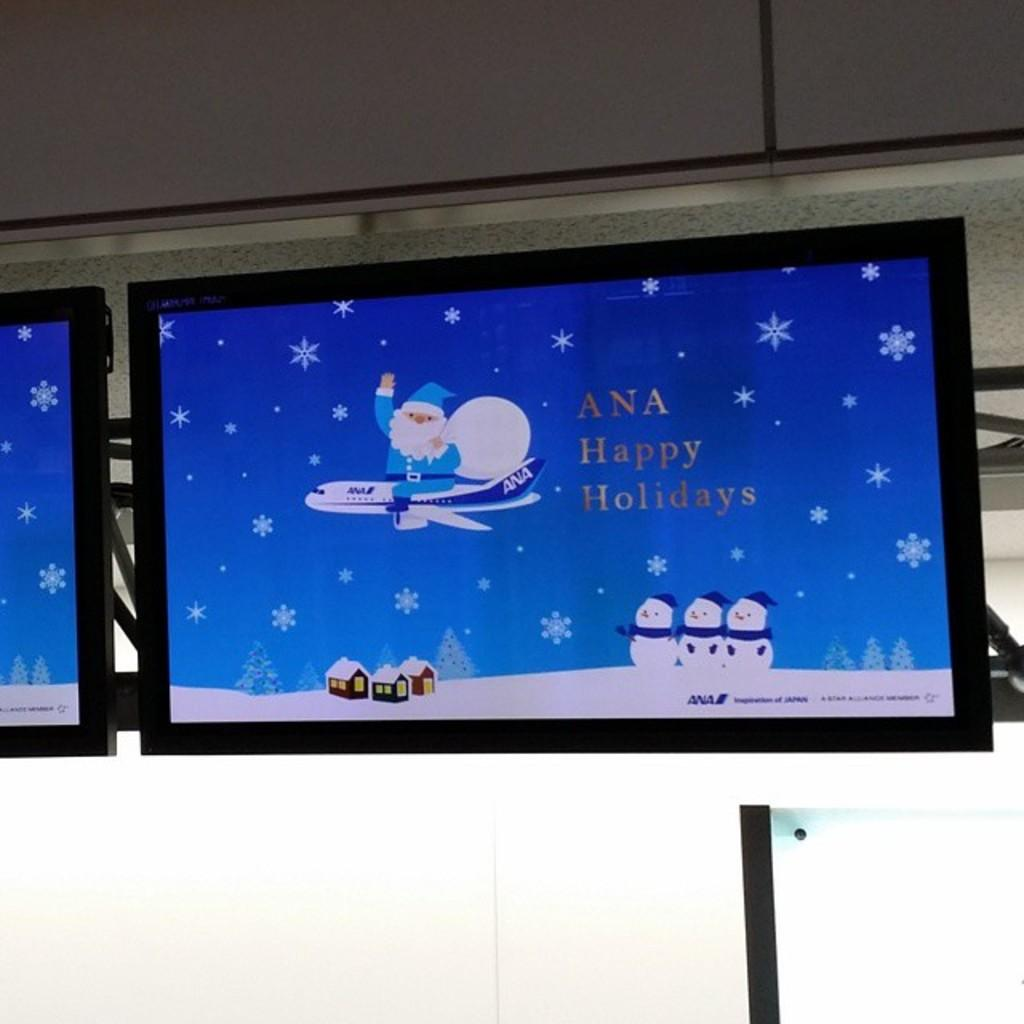<image>
Summarize the visual content of the image. The screen is wishing Ana a Happy Holidays. 